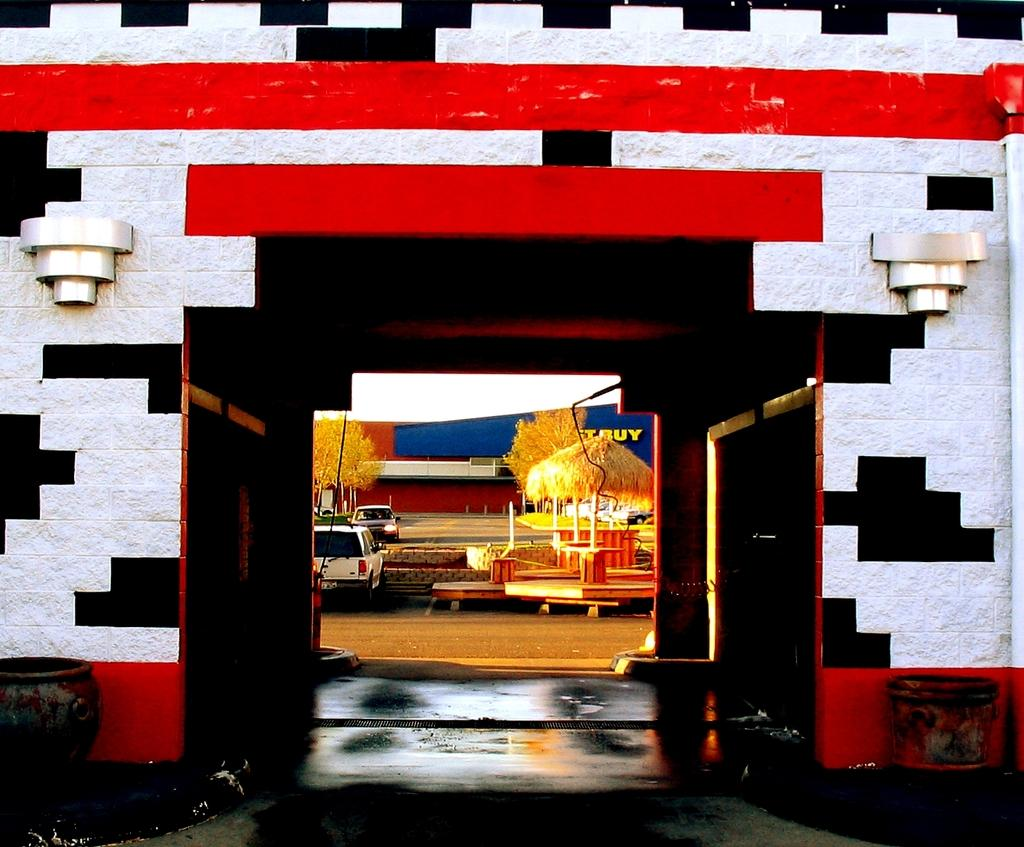What is located in the foreground of the image? There is a wall in the foreground of the image. What is placed on either side of the wall? There are two pots on either side of the wall. What can be seen in the background of the image? There is a hut-like object, vehicles, trees, a building, and the sky visible in the background of the image. What type of language is being spoken by the quartz in the image? There is no quartz present in the image, and therefore no language being spoken by it. 